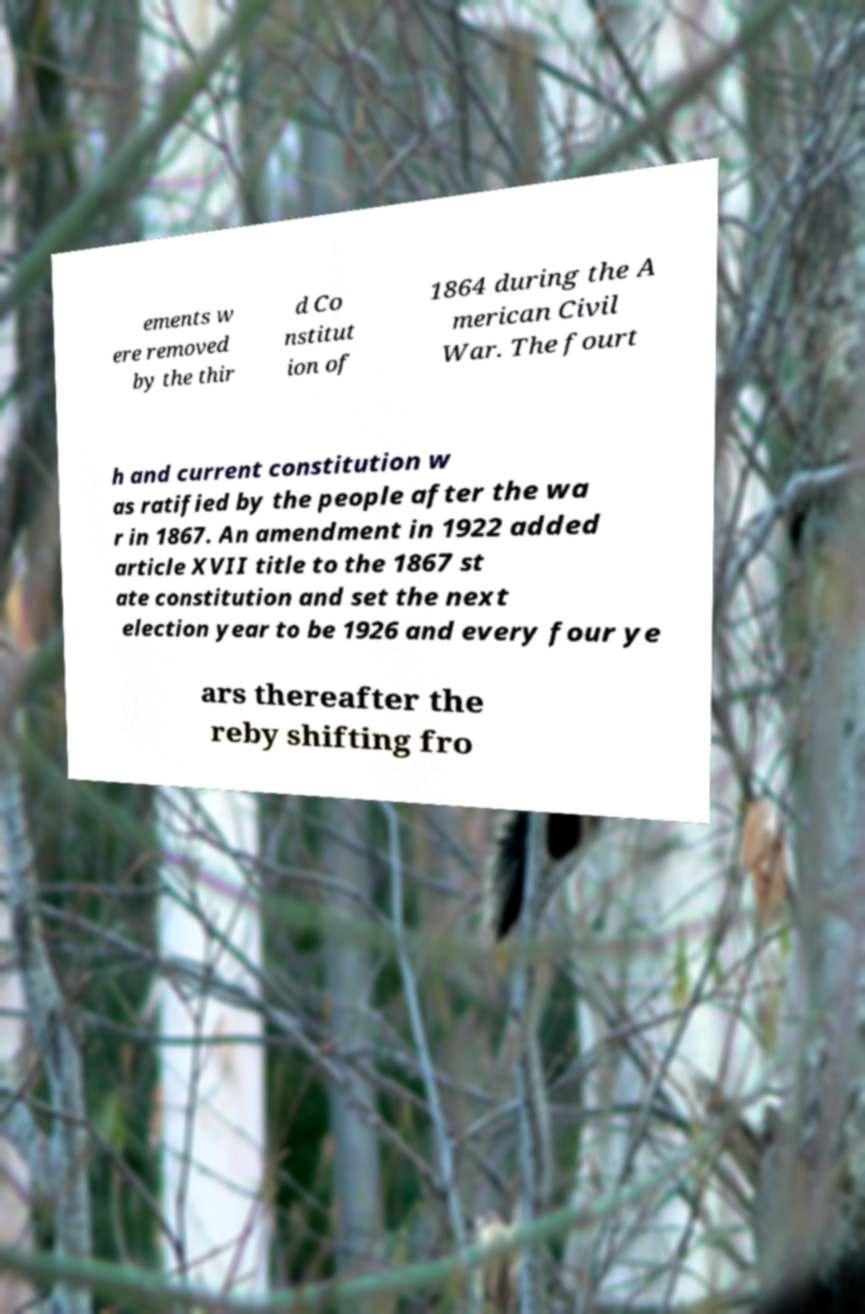Please identify and transcribe the text found in this image. ements w ere removed by the thir d Co nstitut ion of 1864 during the A merican Civil War. The fourt h and current constitution w as ratified by the people after the wa r in 1867. An amendment in 1922 added article XVII title to the 1867 st ate constitution and set the next election year to be 1926 and every four ye ars thereafter the reby shifting fro 